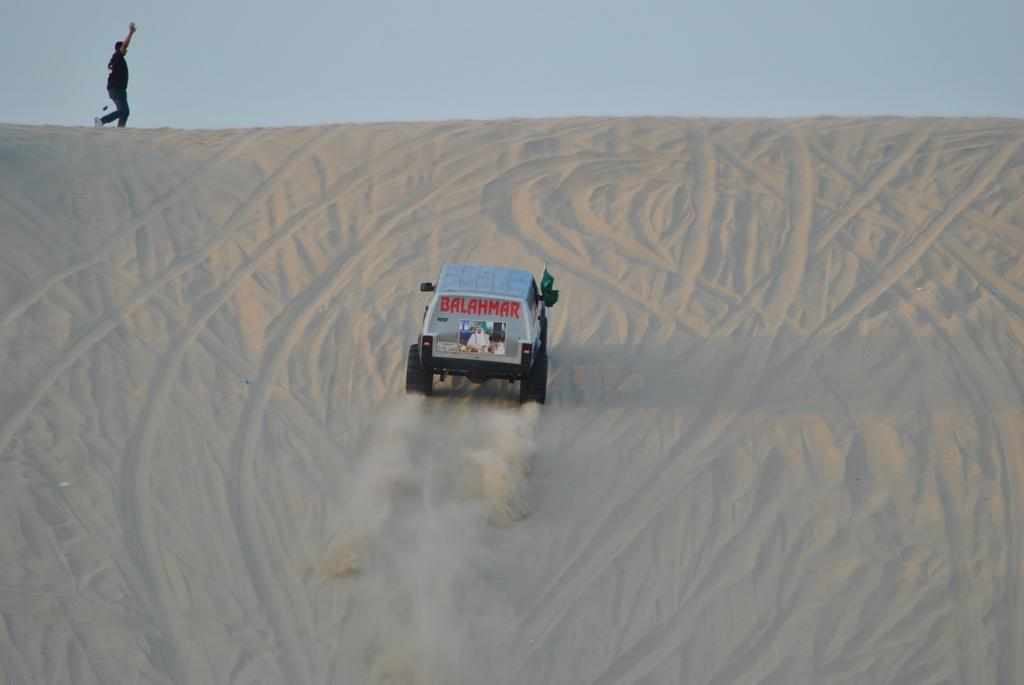What type of food is depicted in the image? There is a dessert in the image. What else is present on the dessert? There is a vehicle on the dessert. Can you describe the person in the image? There is a person in the image. What can be seen in the background of the image? The sky is visible in the image. What type of wool is being used by the servant in the image? There is no wool or servant present in the image. What liquid is being poured by the person in the image? There is no liquid being poured in the image; the person is not performing any action involving a liquid. 